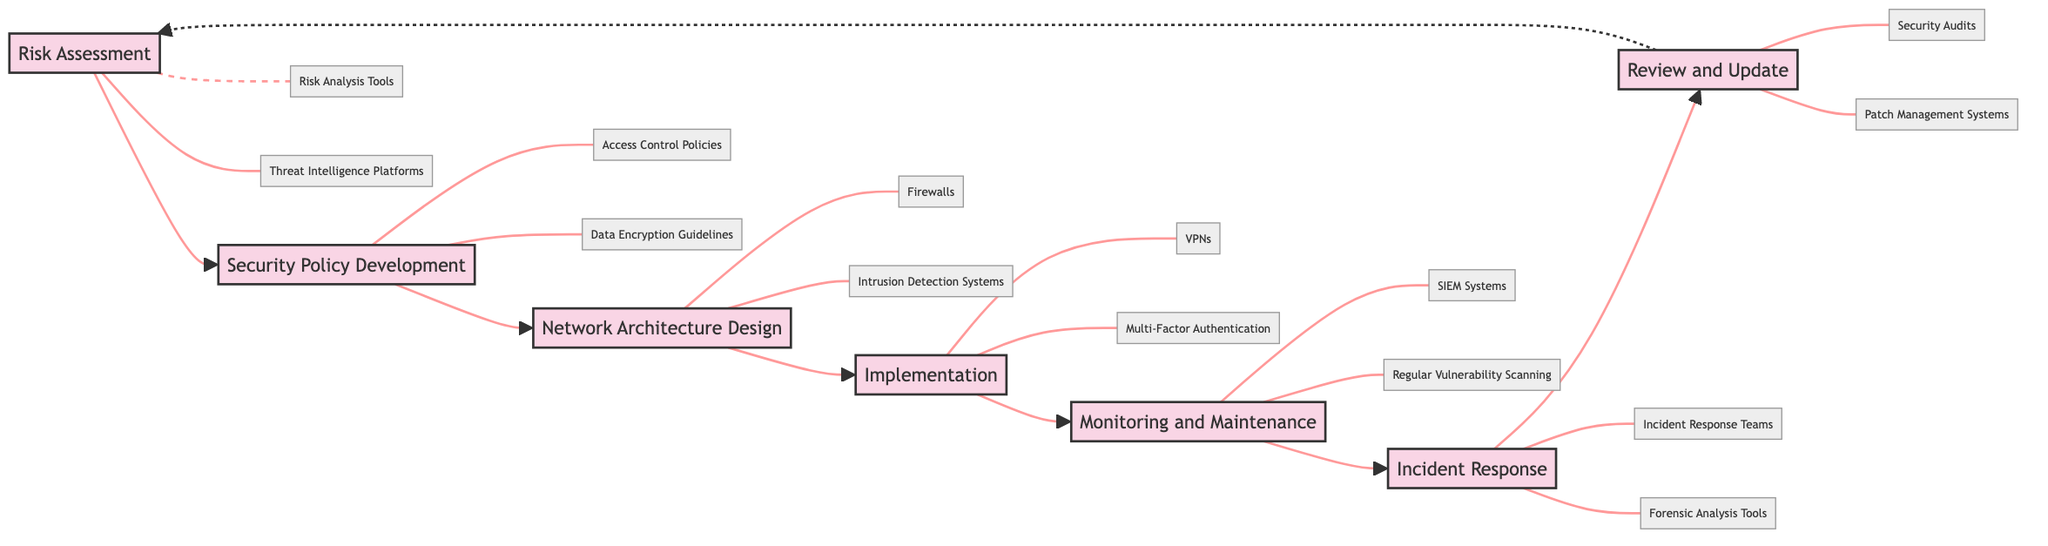What is the first step in the mobile network security lifecycle? According to the flowchart, the first step listed is "Risk Assessment." Therefore, this is the initial action taken in the mobile network security lifecycle.
Answer: Risk Assessment How many steps are there in total? The flowchart outlines a total of seven steps from "Risk Assessment" to "Review and Update." Each of these steps contributes to strengthening mobile network security.
Answer: 7 Which step comes after "Network Architecture Design"? Following the flowchart's sequence, "Implementation" comes next after "Network Architecture Design." This indicates that once the architecture is designed, security measures are deployed.
Answer: Implementation What are the entities listed under "Incident Response"? The flowchart shows "Incident Response Teams" and "Forensic Analysis Tools" as the entities associated with the "Incident Response" step, indicating the resources needed to address security incidents.
Answer: Incident Response Teams, Forensic Analysis Tools What is the relationship between "Review and Update" and "Risk Assessment"? The flowchart illustrates a dashed line from "Review and Update" back to "Risk Assessment," suggesting a cyclical relationship where reviewing updates may lead to a reassessment of risks once new threats are identified.
Answer: Cyclical What is a common factor between "Monitoring and Maintenance" and "Implementation"? Both steps involve critical security measures: "Monitoring and Maintenance" is focused on ongoing vigilance, while "Implementation" is about deploying effective security tools. The common factor is that they both deal with the deployment and supervision of security measures.
Answer: Security Measures Name one of the entities that support "Security Policy Development". The diagram lists "Access Control Policies" and "Data Encryption Guidelines" as entities associated with "Security Policy Development," highlighting the elements that govern secure practices.
Answer: Access Control Policies What is the nature of the connection from "Review and Update" to "Risk Assessment"? The connection is depicted with a dashed arrow in the flowchart, indicating it is a periodic and feedback-driven relationship rather than a direct or sequential one. This reflects the ongoing process of updating security measures based on identified risks.
Answer: Feedback-driven What step involves the use of SIEM Systems? In the flowchart, "Monitoring and Maintenance" is the step associated with the utilization of "SIEM Systems," indicating its role in real-time network monitoring.
Answer: Monitoring and Maintenance 